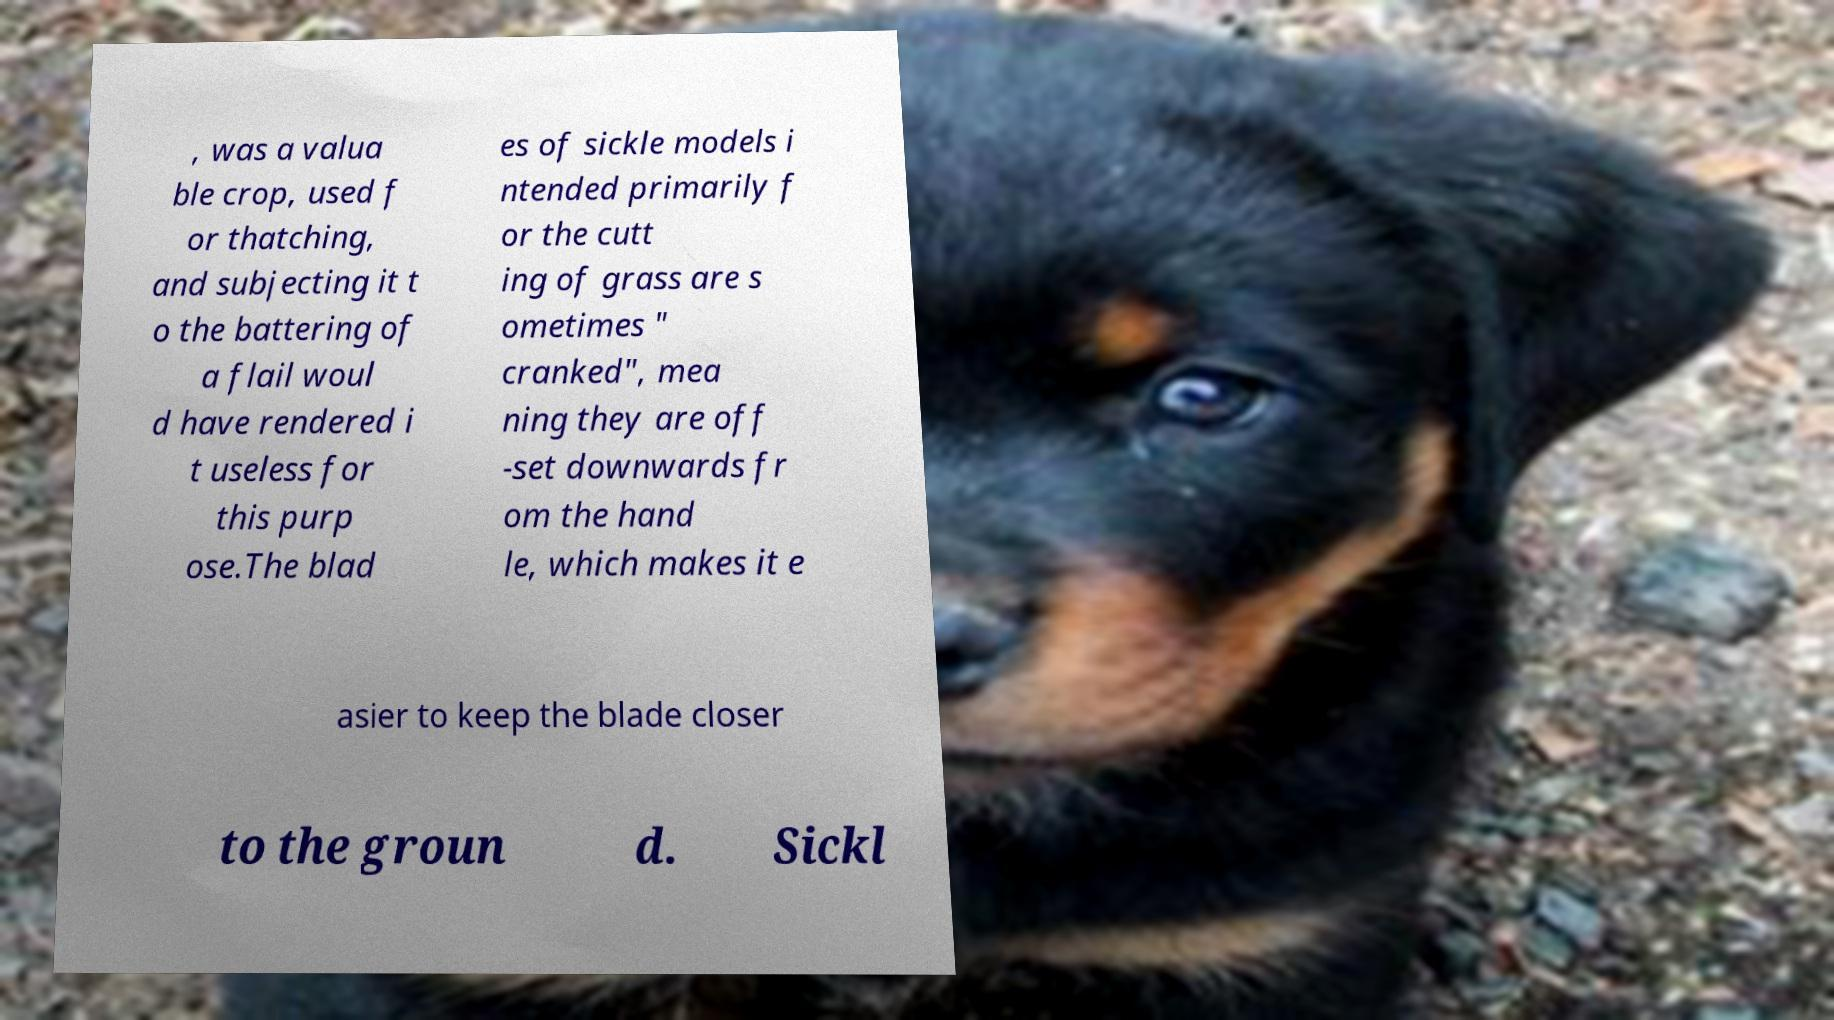There's text embedded in this image that I need extracted. Can you transcribe it verbatim? , was a valua ble crop, used f or thatching, and subjecting it t o the battering of a flail woul d have rendered i t useless for this purp ose.The blad es of sickle models i ntended primarily f or the cutt ing of grass are s ometimes " cranked", mea ning they are off -set downwards fr om the hand le, which makes it e asier to keep the blade closer to the groun d. Sickl 